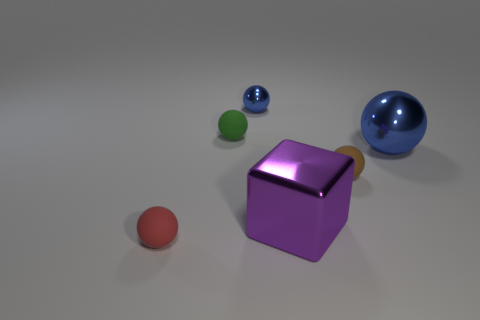There is a large thing that is the same color as the tiny metal ball; what shape is it?
Your answer should be very brief. Sphere. How many things are large metal objects that are on the right side of the purple shiny block or large metal objects that are left of the big sphere?
Your answer should be compact. 2. Does the metallic sphere behind the large blue sphere have the same color as the tiny object to the right of the small blue metal thing?
Keep it short and to the point. No. There is a metal object that is both behind the purple object and to the left of the large blue ball; what shape is it?
Provide a short and direct response. Sphere. What is the color of the metallic ball that is the same size as the brown matte ball?
Provide a short and direct response. Blue. Are there any large shiny cubes of the same color as the tiny metallic thing?
Ensure brevity in your answer.  No. Is the size of the blue thing that is left of the small brown ball the same as the green sphere that is left of the big blue shiny ball?
Ensure brevity in your answer.  Yes. What material is the object that is both in front of the small brown rubber thing and behind the small red thing?
Provide a succinct answer. Metal. The sphere that is the same color as the small metallic object is what size?
Offer a very short reply. Large. What number of other things are the same size as the purple metal block?
Ensure brevity in your answer.  1. 